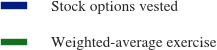Convert chart to OTSL. <chart><loc_0><loc_0><loc_500><loc_500><pie_chart><fcel>Stock options vested<fcel>Weighted-average exercise<nl><fcel>100.0%<fcel>0.0%<nl></chart> 